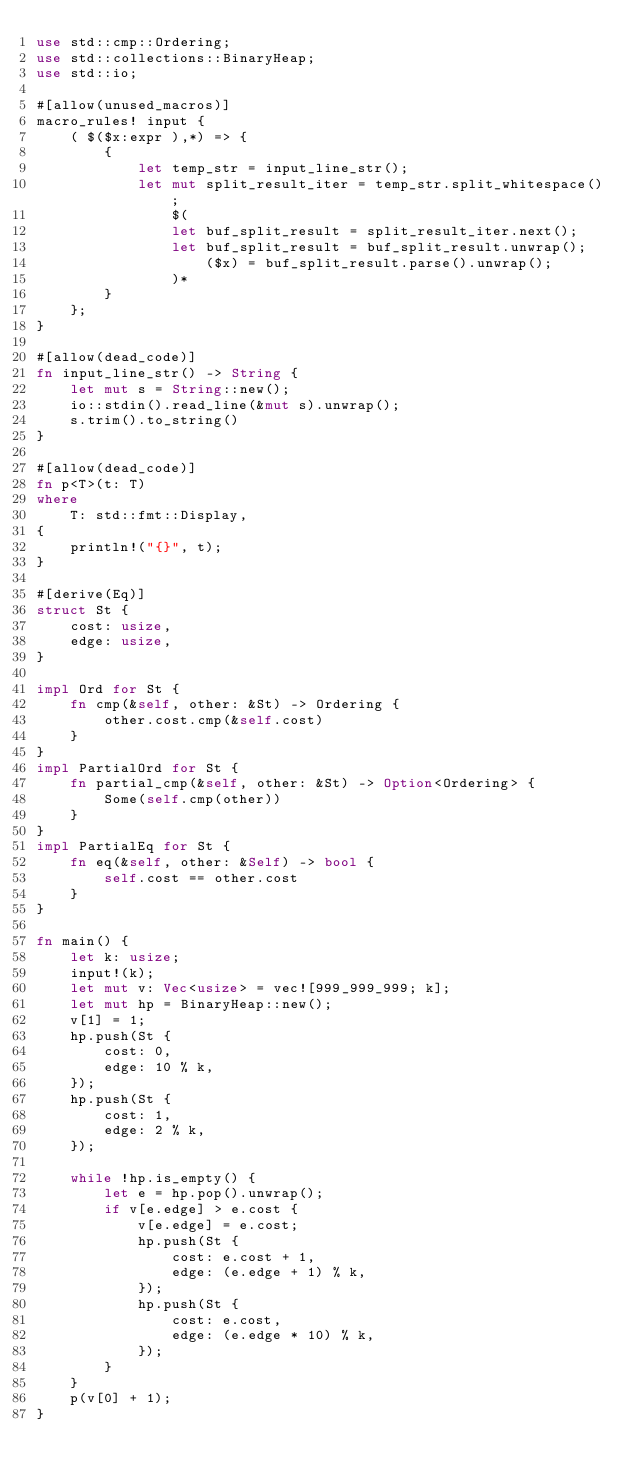Convert code to text. <code><loc_0><loc_0><loc_500><loc_500><_Rust_>use std::cmp::Ordering;
use std::collections::BinaryHeap;
use std::io;

#[allow(unused_macros)]
macro_rules! input {
    ( $($x:expr ),*) => {
        {
            let temp_str = input_line_str();
            let mut split_result_iter = temp_str.split_whitespace();
                $(
                let buf_split_result = split_result_iter.next();
                let buf_split_result = buf_split_result.unwrap();
                    ($x) = buf_split_result.parse().unwrap();
                )*
        }
    };
}

#[allow(dead_code)]
fn input_line_str() -> String {
    let mut s = String::new();
    io::stdin().read_line(&mut s).unwrap();
    s.trim().to_string()
}

#[allow(dead_code)]
fn p<T>(t: T)
where
    T: std::fmt::Display,
{
    println!("{}", t);
}

#[derive(Eq)]
struct St {
    cost: usize,
    edge: usize,
}

impl Ord for St {
    fn cmp(&self, other: &St) -> Ordering {
        other.cost.cmp(&self.cost)
    }
}
impl PartialOrd for St {
    fn partial_cmp(&self, other: &St) -> Option<Ordering> {
        Some(self.cmp(other))
    }
}
impl PartialEq for St {
    fn eq(&self, other: &Self) -> bool {
        self.cost == other.cost
    }
}

fn main() {
    let k: usize;
    input!(k);
    let mut v: Vec<usize> = vec![999_999_999; k];
    let mut hp = BinaryHeap::new();
    v[1] = 1;
    hp.push(St {
        cost: 0,
        edge: 10 % k,
    });
    hp.push(St {
        cost: 1,
        edge: 2 % k,
    });

    while !hp.is_empty() {
        let e = hp.pop().unwrap();
        if v[e.edge] > e.cost {
            v[e.edge] = e.cost;
            hp.push(St {
                cost: e.cost + 1,
                edge: (e.edge + 1) % k,
            });
            hp.push(St {
                cost: e.cost,
                edge: (e.edge * 10) % k,
            });
        }
    }
    p(v[0] + 1);
}</code> 